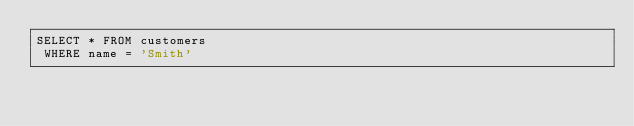Convert code to text. <code><loc_0><loc_0><loc_500><loc_500><_SQL_>SELECT * FROM customers
 WHERE name = 'Smith'
</code> 